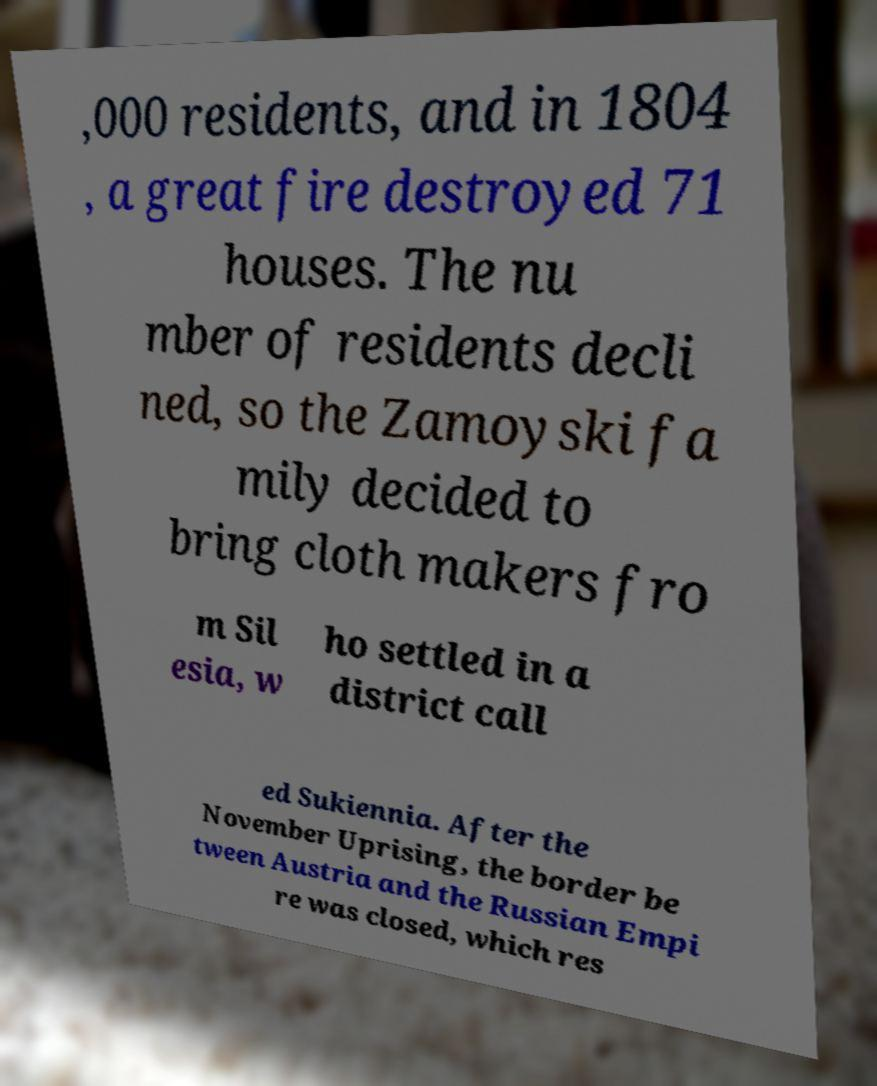Could you assist in decoding the text presented in this image and type it out clearly? ,000 residents, and in 1804 , a great fire destroyed 71 houses. The nu mber of residents decli ned, so the Zamoyski fa mily decided to bring cloth makers fro m Sil esia, w ho settled in a district call ed Sukiennia. After the November Uprising, the border be tween Austria and the Russian Empi re was closed, which res 